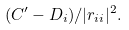<formula> <loc_0><loc_0><loc_500><loc_500>( C ^ { \prime } - D _ { i } ) / | r _ { i i } | ^ { 2 } .</formula> 